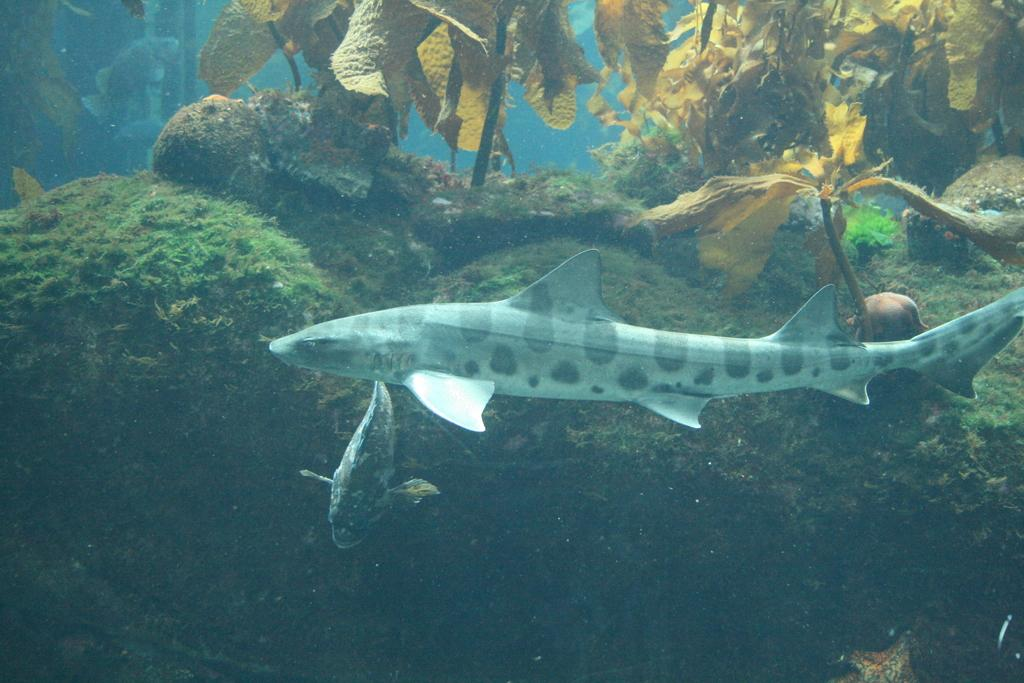What type of animals can be seen in the image? There are fish visible in the image. Where are the fish located? The fish are underwater in the image. What type of rocks can be seen in the image? There are coral rocks in the image. What other living organisms are present in the image? Sea plants are present in the image. How does the celery contribute to the pollution in the image? There is no celery present in the image, and therefore it cannot contribute to any pollution. 